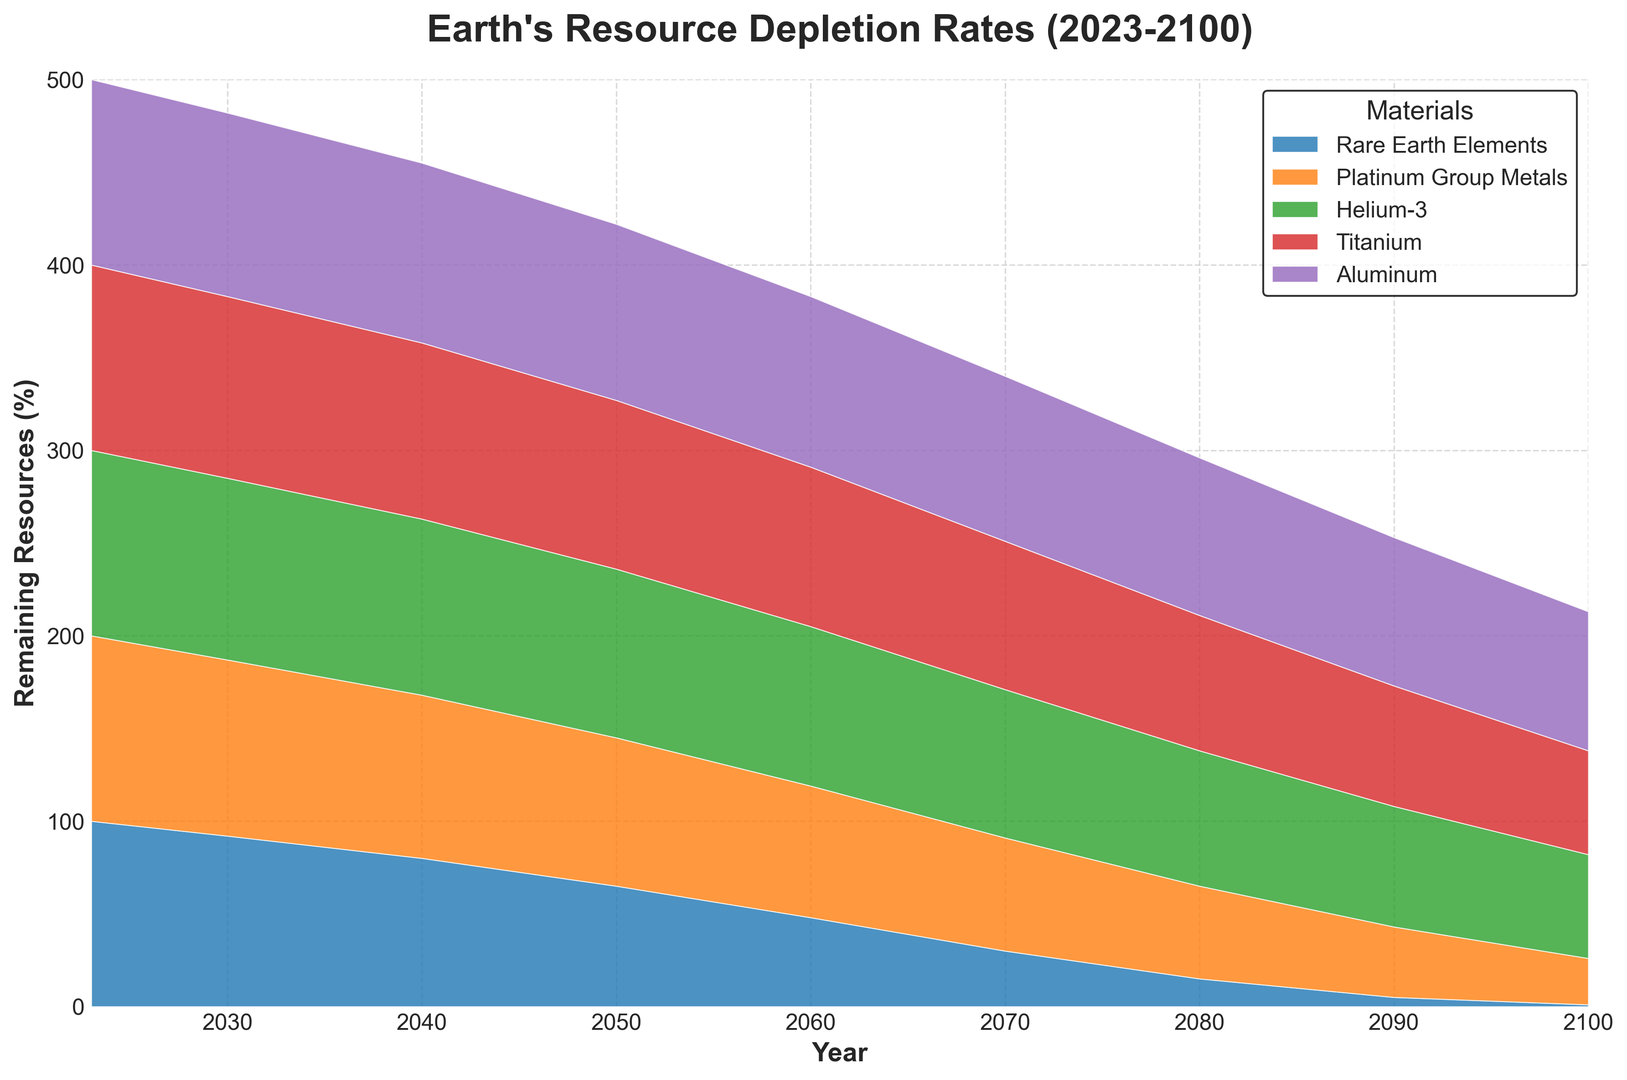What percentage of Rare Earth Elements remains in 2060? Look at the 'Rare Earth Elements' plot line and find the value on the y-axis corresponding to the year 2060.
Answer: 48% Which material is expected to deplete the most by the year 2100? Compare the values of all materials in the year 2100 and find which one has the lowest percentage remaining. Rare Earth Elements have the lowest percentage at 1%.
Answer: Rare Earth Elements In which year does Helium-3 drop below 50% remaining? Find the year where the 'Helium-3' line first falls below the 50% mark on the y-axis.
Answer: 2090 By how much does the percentage of Aluminum decrease between 2030 and 2070? Look at the value of Aluminum in 2030 and subtract the value in 2070 to find the decrease. Aluminum is at 99% in 2030 and 89% in 2070, calculating 99 - 89 gives the result.
Answer: 10% Which material is projected to have the highest remaining percentage in 2080? For the year 2080, compare the remaining percentages of all materials and determine which one is the highest. Titanium has the highest percentage at 73%.
Answer: Titanium What is the average percentage remaining of Platinum Group Metals from 2030 to 2050? Add the remaining percentages of Platinum Group Metals for 2030, 2040, and 2050, then divide by 3. (95 + 88 + 80) / 3 = 87.67
Answer: 87.67% How does the percentage of Titanium remaining in 2040 compare to that of Helium-3 in 2090? Find and compare the values of Titanium in 2040 (95%) and Helium-3 in 2090 (65%). 95% is greater than 65%.
Answer: Greater than What is the difference in the percentage remaining of Rare Earth Elements between 2040 and 2100? Subtract the 2100 value from the 2040 value for Rare Earth Elements. 80 - 1 = 79
Answer: 79% At what year does Platinum Group Metals drop to half of its initial value in 2023? Find the year where the remaining percentage of Platinum Group Metals first equals 50% of its initial value (100% in 2023), which means finding when it reaches 50%.
Answer: 2080 Which material shows the fastest depletion rate between 2023 and 2050? Compare the steepness of the declines of all materials between 2023 and 2050, determining that Rare Earth Elements decline the most rapidly.
Answer: Rare Earth Elements 